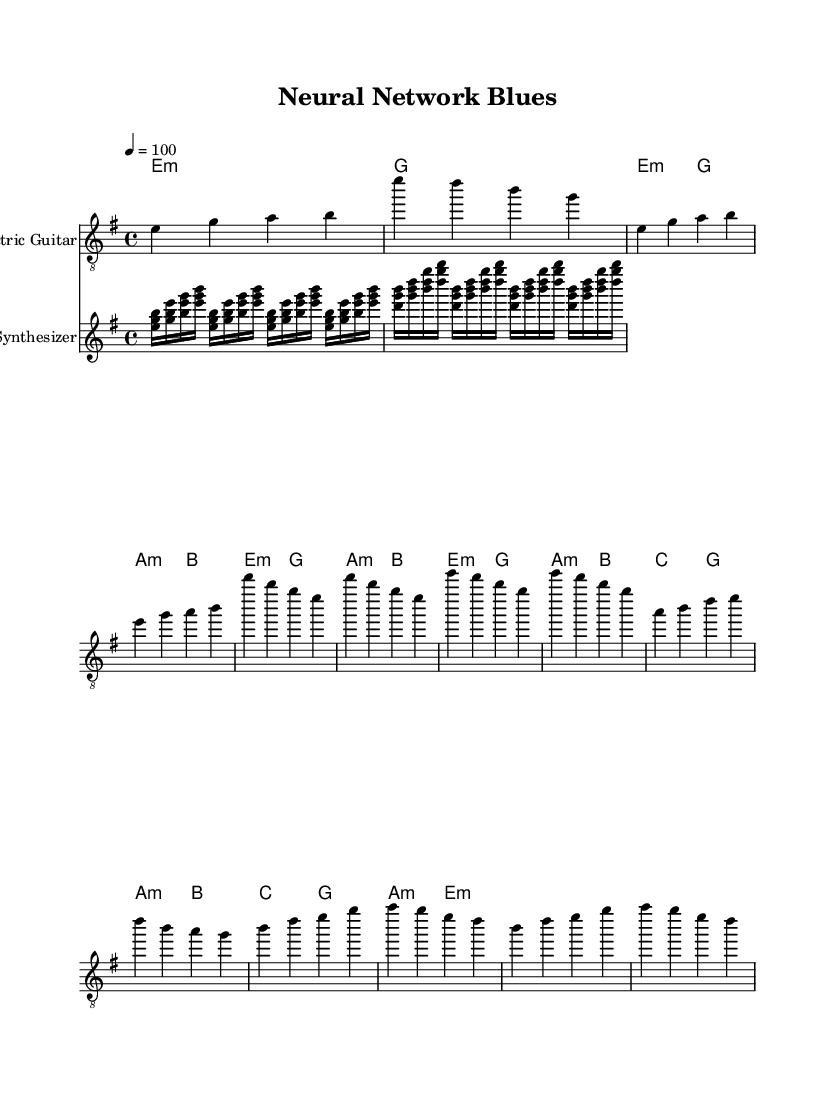What is the key signature of this music? The key signature is indicated by the number of sharps or flats. In this case, it shows E minor which is represented with one sharp (F#).
Answer: E minor What is the time signature of this piece? The time signature is located at the beginning, expressing how many beats are in each measure. Here, it's noted as 4/4, which means there are 4 beats per measure.
Answer: 4/4 What is the tempo of the piece? The tempo is indicated in beats per minute (BPM). In the score, it is marked as "4 = 100," meaning there are 100 beats per minute.
Answer: 100 What instruments are used in this score? The instruments are specified at the start of each staff. There is an Electric Guitar and a Synthesizer indicated in the score.
Answer: Electric Guitar, Synthesizer How many measures are in the intro? To find the number of measures in the intro, count the individual segments divided by vertical lines (bar lines) in the intro section: there are 2 measures.
Answer: 2 What type of chords are primarily used in the verse section? The verse section shows a progression of minor and major chords. Specifically, the chords E minor and A minor dominate in the verse.
Answer: E minor, A minor Describe the primary element of the synth line. The synth line features glitchy arpeggios that create an experimental digital sound. It's constructed using quick 16th note patterns that alternate between different chords.
Answer: Glitchy arpeggios 